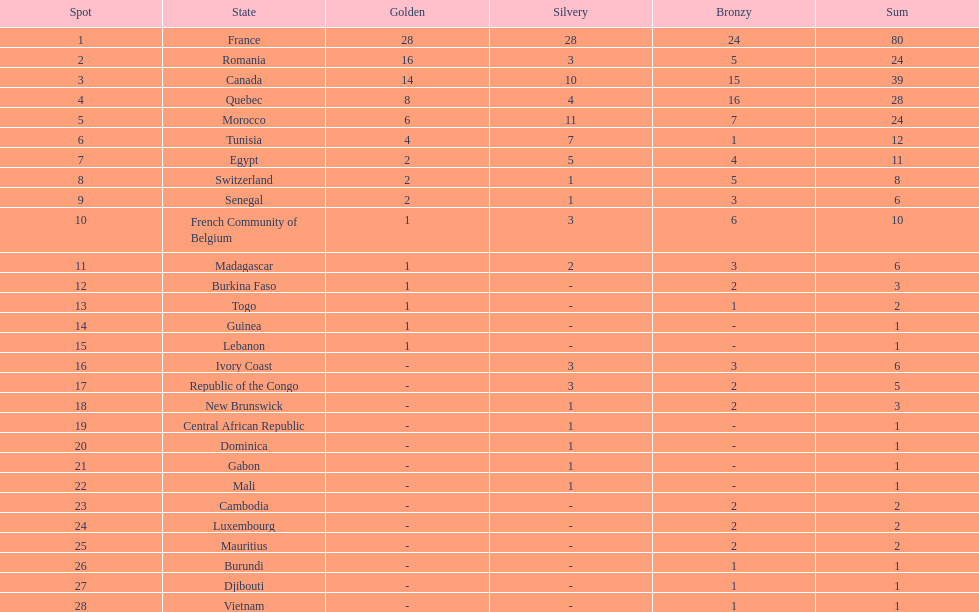Would you be able to parse every entry in this table? {'header': ['Spot', 'State', 'Golden', 'Silvery', 'Bronzy', 'Sum'], 'rows': [['1', 'France', '28', '28', '24', '80'], ['2', 'Romania', '16', '3', '5', '24'], ['3', 'Canada', '14', '10', '15', '39'], ['4', 'Quebec', '8', '4', '16', '28'], ['5', 'Morocco', '6', '11', '7', '24'], ['6', 'Tunisia', '4', '7', '1', '12'], ['7', 'Egypt', '2', '5', '4', '11'], ['8', 'Switzerland', '2', '1', '5', '8'], ['9', 'Senegal', '2', '1', '3', '6'], ['10', 'French Community of Belgium', '1', '3', '6', '10'], ['11', 'Madagascar', '1', '2', '3', '6'], ['12', 'Burkina Faso', '1', '-', '2', '3'], ['13', 'Togo', '1', '-', '1', '2'], ['14', 'Guinea', '1', '-', '-', '1'], ['15', 'Lebanon', '1', '-', '-', '1'], ['16', 'Ivory Coast', '-', '3', '3', '6'], ['17', 'Republic of the Congo', '-', '3', '2', '5'], ['18', 'New Brunswick', '-', '1', '2', '3'], ['19', 'Central African Republic', '-', '1', '-', '1'], ['20', 'Dominica', '-', '1', '-', '1'], ['21', 'Gabon', '-', '1', '-', '1'], ['22', 'Mali', '-', '1', '-', '1'], ['23', 'Cambodia', '-', '-', '2', '2'], ['24', 'Luxembourg', '-', '-', '2', '2'], ['25', 'Mauritius', '-', '-', '2', '2'], ['26', 'Burundi', '-', '-', '1', '1'], ['27', 'Djibouti', '-', '-', '1', '1'], ['28', 'Vietnam', '-', '-', '1', '1']]} Who placed in first according to medals? France. 